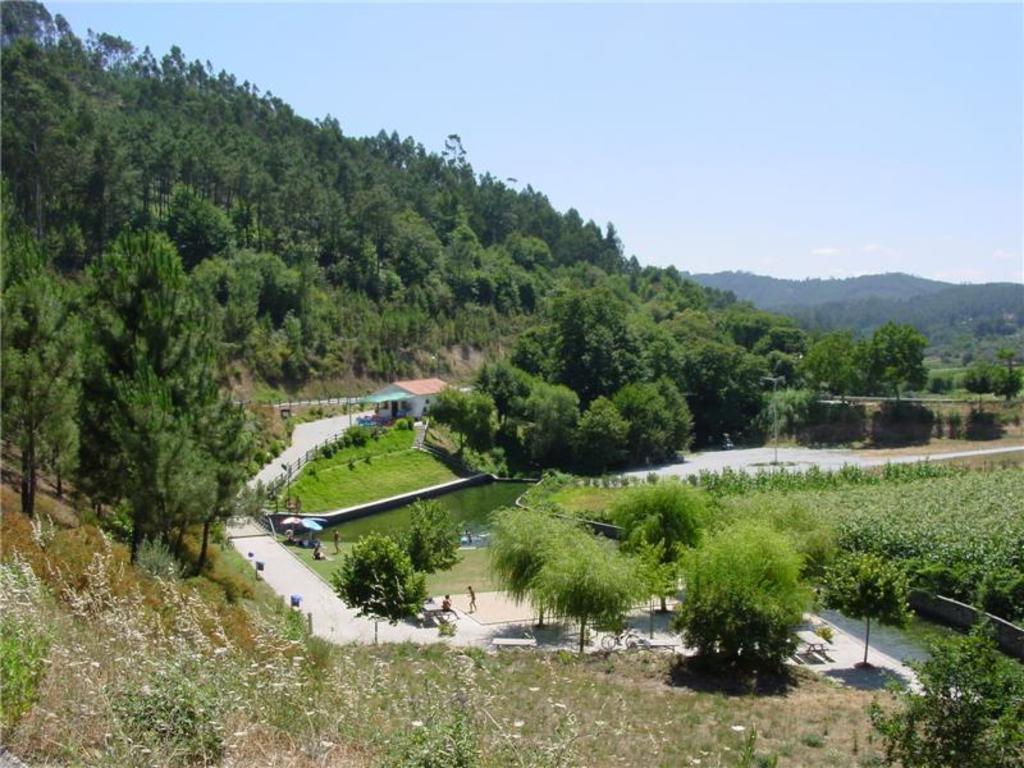Can you describe this image briefly? In the center of the image there are trees. There is grass. In the background of the image there are mountains. 